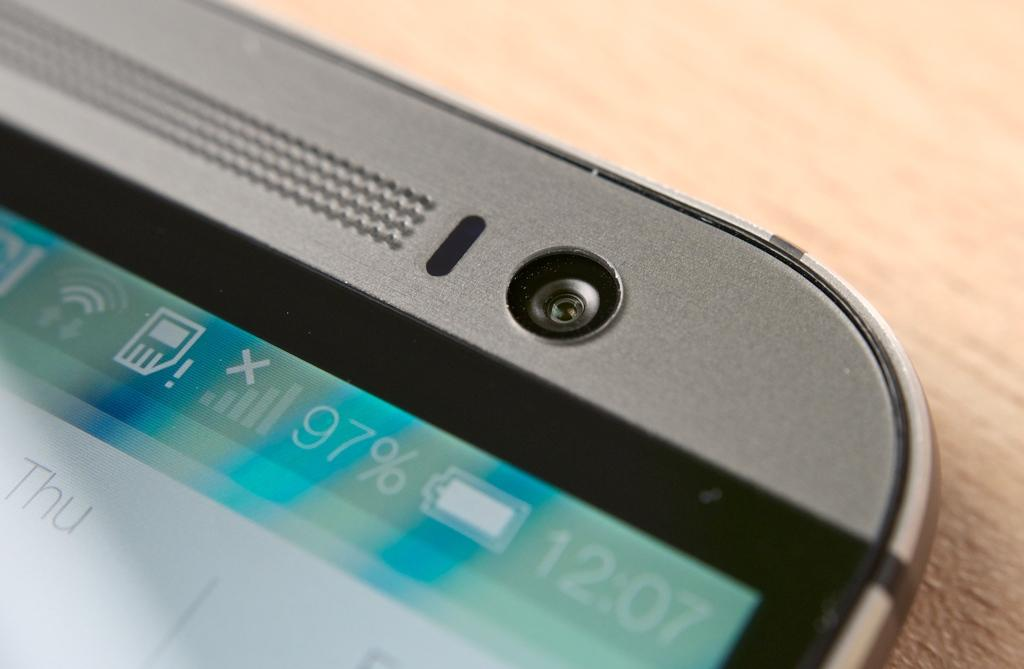<image>
Share a concise interpretation of the image provided. The top of the screen states that it is 12:07 and the battery is at 97%. 